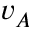Convert formula to latex. <formula><loc_0><loc_0><loc_500><loc_500>v _ { A }</formula> 